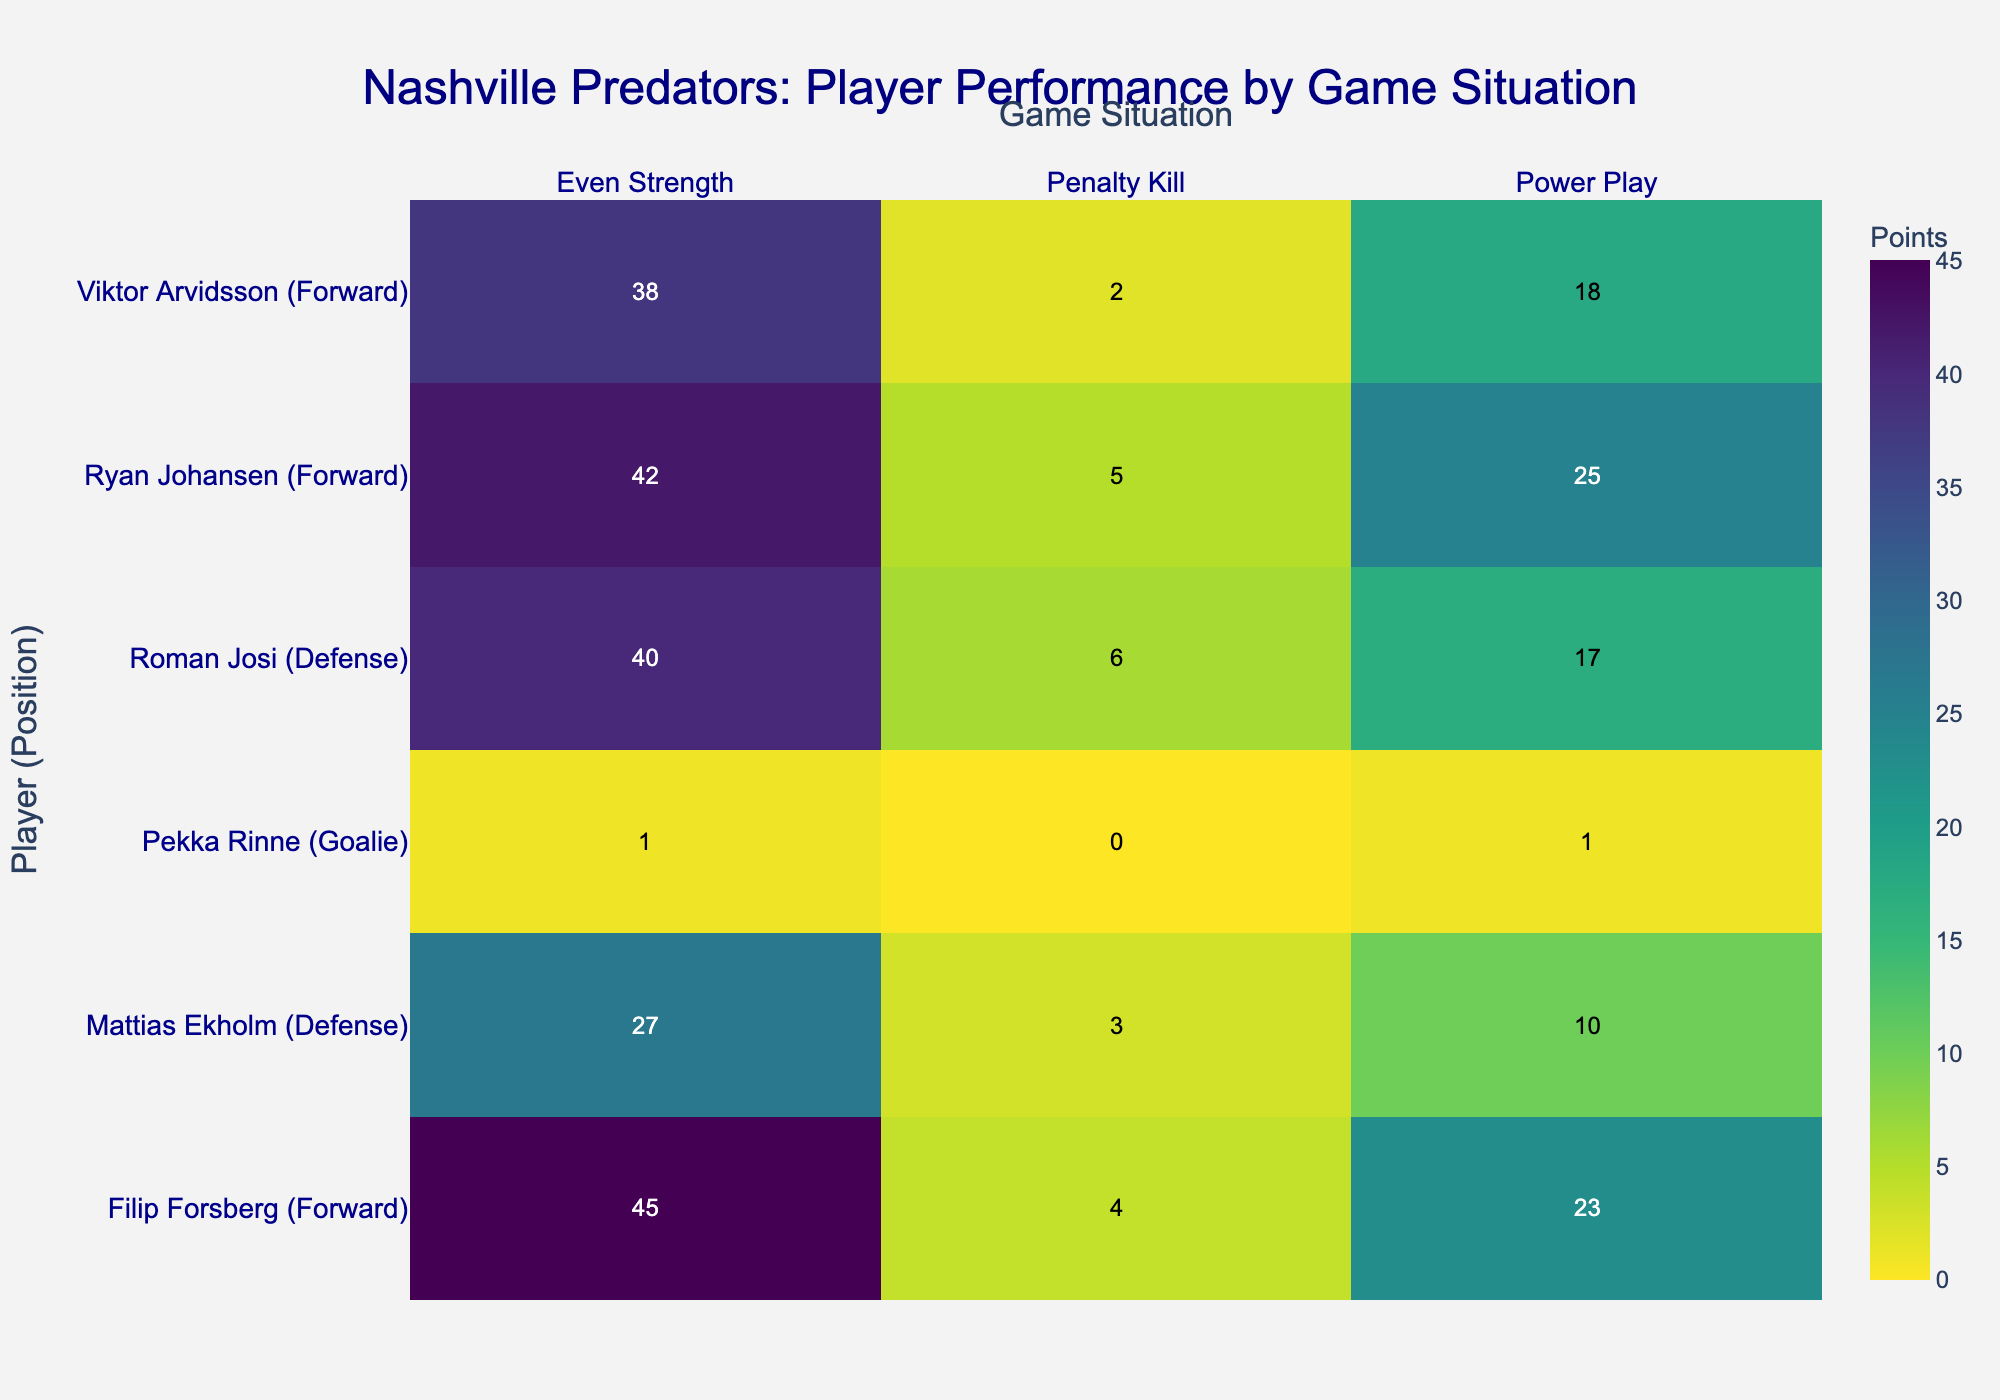What's the title of the figure? The title of the figure is prominently displayed at the top in a large font.
Answer: Nashville Predators: Player Performance by Game Situation Which player and position combination has the highest points in an Even Strength situation? By looking at the row with the highest value under the "Even Strength" column, we see that Filip Forsberg (Forward) has the highest points.
Answer: Filip Forsberg (Forward) How many total points does Roman Josi (Defense) have across all game situations? Sum the values for Roman Josi (Defense) under all game situations: 17 (Power Play) + 40 (Even Strength) + 6 (Penalty Kill) = 63.
Answer: 63 Compare the performance of Ryan Johansen (Forward) and Viktor Arvidsson (Forward) in Power Play and Even Strength situations. Who has more points overall? Ryan Johansen has 25 points in Power Play and 42 in Even Strength. Viktor Arvidsson has 18 points in Power Play and 38 in Even Strength. Summing them up, Ryan Johansen has 67 points, while Viktor Arvidsson has 56 points.
Answer: Ryan Johansen Is there any player who has scored points in every game situation? By checking each player's data across all game situations, Filip Forsberg (Forward) and Roman Josi (Defense) have points in Power Play, Even Strength, and Penalty Kill situations.
Answer: Yes, Filip Forsberg (Forward) and Roman Josi (Defense) Which game situation leads to the lowest points for Mattias Ekholm (Defense)? Checking the values for Mattias Ekholm (Defense) across game situations, Penalty Kill has the lowest points with a value of 3.
Answer: Penalty Kill What is the total number of points scored by all players in Power Play situations? Sum the points for all players under Power Play: 17 + 23 + 25 + 10 + 18 = 93.
Answer: 93 Identify the position with the highest average points in Even Strength situations. Calculate the average points for each position in Even Strength situations. Forwards: (45 + 42 + 38) / 3 = 41.67. Defense: (40 + 27) / 2 = 33.5. Forwards have the highest average points.
Answer: Forward Which player has the lowest points in the Penalty Kill situation? By finding the lowest value under the "Penalty Kill," we observe that Pekka Rinne (Goalie) has 0 points.
Answer: Pekka Rinne (Goalie) How does the performance of goalies compare to other positions in Power Play situations? Check the Power Play points for Pekka Rinne (Goalie), which is 1. Compare it to the minimum points for forwards and defenses, which is 10 and 17, respectively. Goalies score significantly fewer points.
Answer: Goalies score fewer points in Power Play 